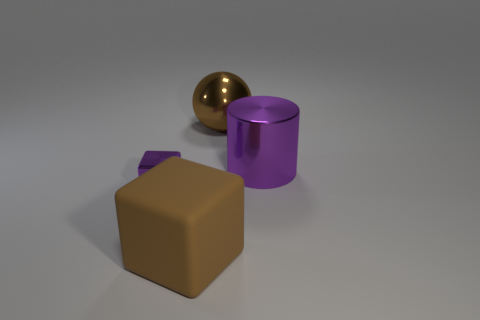Is the number of matte things greater than the number of red rubber cubes?
Ensure brevity in your answer.  Yes. Is there a small metallic block?
Your answer should be compact. Yes. What number of things are things on the left side of the brown block or big metallic things that are on the left side of the large purple cylinder?
Your response must be concise. 2. Is the big sphere the same color as the metal cylinder?
Provide a short and direct response. No. Is the number of large purple shiny blocks less than the number of big purple metallic things?
Give a very brief answer. Yes. There is a big rubber cube; are there any purple cylinders in front of it?
Your answer should be compact. No. Is the material of the purple block the same as the brown ball?
Make the answer very short. Yes. There is a large object that is the same shape as the tiny purple metallic object; what is its color?
Make the answer very short. Brown. Do the block that is behind the big brown rubber thing and the sphere have the same color?
Make the answer very short. No. There is a large object that is the same color as the large block; what is its shape?
Your response must be concise. Sphere. 